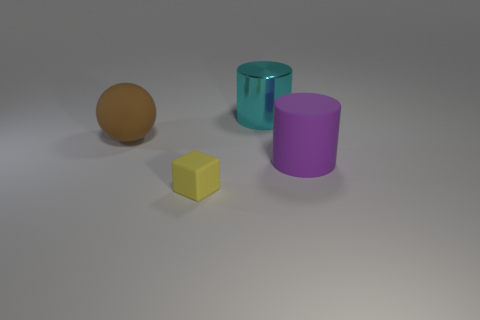Add 1 brown rubber objects. How many objects exist? 5 Subtract all blocks. How many objects are left? 3 Subtract 0 red cubes. How many objects are left? 4 Subtract all big purple shiny cubes. Subtract all large purple rubber cylinders. How many objects are left? 3 Add 2 purple matte cylinders. How many purple matte cylinders are left? 3 Add 4 purple cylinders. How many purple cylinders exist? 5 